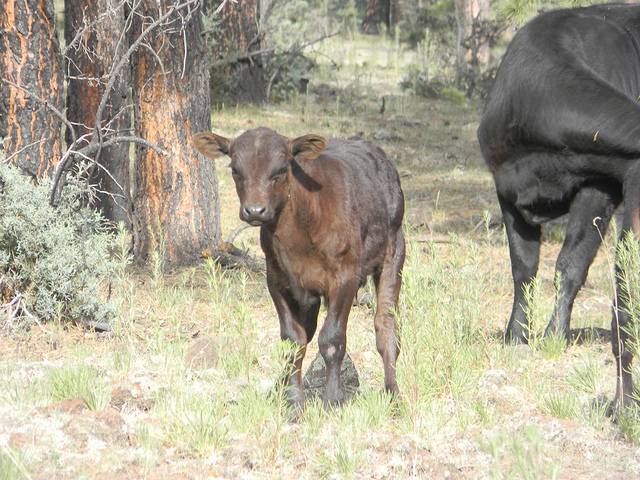<image>What happened to the tree on the left? I don't know exactly what happened to the tree on the left. It could possibly be burned, scraped, or fell over. What happened to the tree on the left? I don't know what happened to the tree on the left. It could be burned, burnt, rubbed, or scraped. 